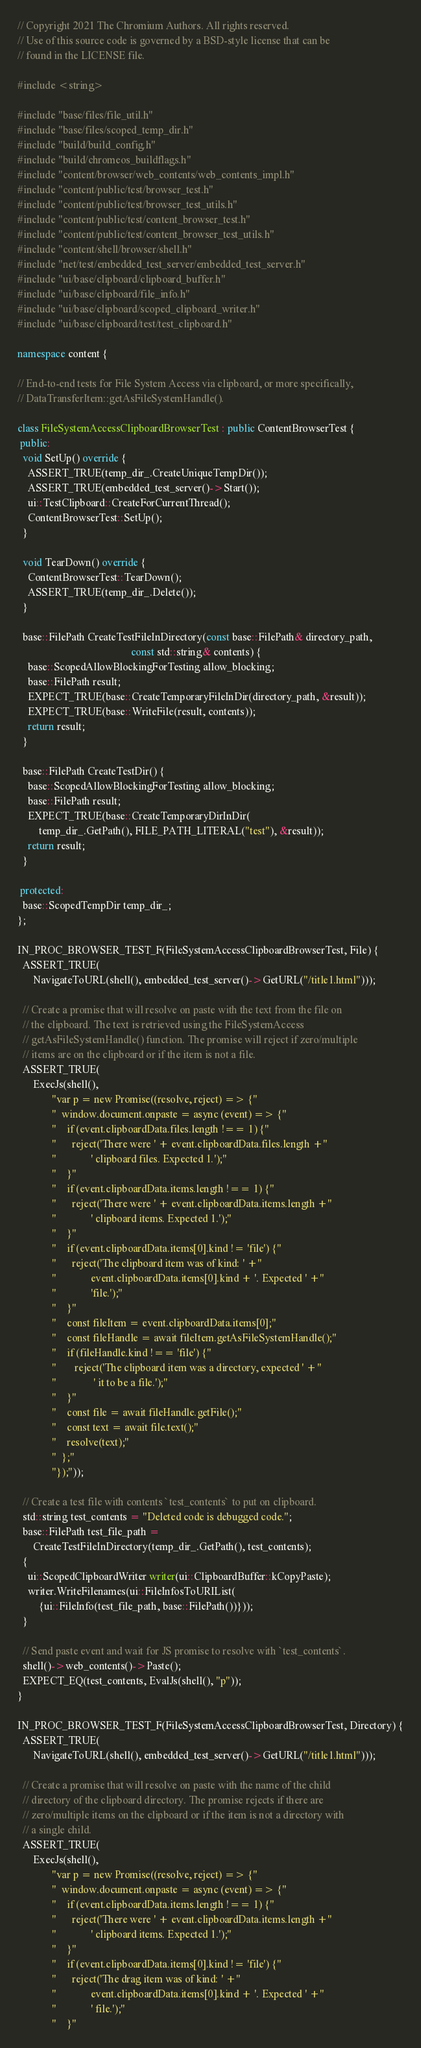<code> <loc_0><loc_0><loc_500><loc_500><_C++_>// Copyright 2021 The Chromium Authors. All rights reserved.
// Use of this source code is governed by a BSD-style license that can be
// found in the LICENSE file.

#include <string>

#include "base/files/file_util.h"
#include "base/files/scoped_temp_dir.h"
#include "build/build_config.h"
#include "build/chromeos_buildflags.h"
#include "content/browser/web_contents/web_contents_impl.h"
#include "content/public/test/browser_test.h"
#include "content/public/test/browser_test_utils.h"
#include "content/public/test/content_browser_test.h"
#include "content/public/test/content_browser_test_utils.h"
#include "content/shell/browser/shell.h"
#include "net/test/embedded_test_server/embedded_test_server.h"
#include "ui/base/clipboard/clipboard_buffer.h"
#include "ui/base/clipboard/file_info.h"
#include "ui/base/clipboard/scoped_clipboard_writer.h"
#include "ui/base/clipboard/test/test_clipboard.h"

namespace content {

// End-to-end tests for File System Access via clipboard, or more specifically,
// DataTransferItem::getAsFileSystemHandle().

class FileSystemAccessClipboardBrowserTest : public ContentBrowserTest {
 public:
  void SetUp() override {
    ASSERT_TRUE(temp_dir_.CreateUniqueTempDir());
    ASSERT_TRUE(embedded_test_server()->Start());
    ui::TestClipboard::CreateForCurrentThread();
    ContentBrowserTest::SetUp();
  }

  void TearDown() override {
    ContentBrowserTest::TearDown();
    ASSERT_TRUE(temp_dir_.Delete());
  }

  base::FilePath CreateTestFileInDirectory(const base::FilePath& directory_path,
                                           const std::string& contents) {
    base::ScopedAllowBlockingForTesting allow_blocking;
    base::FilePath result;
    EXPECT_TRUE(base::CreateTemporaryFileInDir(directory_path, &result));
    EXPECT_TRUE(base::WriteFile(result, contents));
    return result;
  }

  base::FilePath CreateTestDir() {
    base::ScopedAllowBlockingForTesting allow_blocking;
    base::FilePath result;
    EXPECT_TRUE(base::CreateTemporaryDirInDir(
        temp_dir_.GetPath(), FILE_PATH_LITERAL("test"), &result));
    return result;
  }

 protected:
  base::ScopedTempDir temp_dir_;
};

IN_PROC_BROWSER_TEST_F(FileSystemAccessClipboardBrowserTest, File) {
  ASSERT_TRUE(
      NavigateToURL(shell(), embedded_test_server()->GetURL("/title1.html")));

  // Create a promise that will resolve on paste with the text from the file on
  // the clipboard. The text is retrieved using the FileSystemAccess
  // getAsFileSystemHandle() function. The promise will reject if zero/multiple
  // items are on the clipboard or if the item is not a file.
  ASSERT_TRUE(
      ExecJs(shell(),
             "var p = new Promise((resolve, reject) => {"
             "  window.document.onpaste = async (event) => {"
             "    if (event.clipboardData.files.length !== 1) {"
             "      reject('There were ' + event.clipboardData.files.length +"
             "             ' clipboard files. Expected 1.');"
             "    }"
             "    if (event.clipboardData.items.length !== 1) {"
             "      reject('There were ' + event.clipboardData.items.length +"
             "             ' clipboard items. Expected 1.');"
             "    }"
             "    if (event.clipboardData.items[0].kind != 'file') {"
             "      reject('The clipboard item was of kind: ' +"
             "             event.clipboardData.items[0].kind + '. Expected ' +"
             "             'file.');"
             "    }"
             "    const fileItem = event.clipboardData.items[0];"
             "    const fileHandle = await fileItem.getAsFileSystemHandle();"
             "    if (fileHandle.kind !== 'file') {"
             "       reject('The clipboard item was a directory, expected ' +"
             "              ' it to be a file.');"
             "    }"
             "    const file = await fileHandle.getFile();"
             "    const text = await file.text();"
             "    resolve(text);"
             "  };"
             "});"));

  // Create a test file with contents `test_contents` to put on clipboard.
  std::string test_contents = "Deleted code is debugged code.";
  base::FilePath test_file_path =
      CreateTestFileInDirectory(temp_dir_.GetPath(), test_contents);
  {
    ui::ScopedClipboardWriter writer(ui::ClipboardBuffer::kCopyPaste);
    writer.WriteFilenames(ui::FileInfosToURIList(
        {ui::FileInfo(test_file_path, base::FilePath())}));
  }

  // Send paste event and wait for JS promise to resolve with `test_contents`.
  shell()->web_contents()->Paste();
  EXPECT_EQ(test_contents, EvalJs(shell(), "p"));
}

IN_PROC_BROWSER_TEST_F(FileSystemAccessClipboardBrowserTest, Directory) {
  ASSERT_TRUE(
      NavigateToURL(shell(), embedded_test_server()->GetURL("/title1.html")));

  // Create a promise that will resolve on paste with the name of the child
  // directory of the clipboard directory. The promise rejects if there are
  // zero/multiple items on the clipboard or if the item is not a directory with
  // a single child.
  ASSERT_TRUE(
      ExecJs(shell(),
             "var p = new Promise((resolve, reject) => {"
             "  window.document.onpaste = async (event) => {"
             "    if (event.clipboardData.items.length !== 1) {"
             "      reject('There were ' + event.clipboardData.items.length +"
             "             ' clipboard items. Expected 1.');"
             "    }"
             "    if (event.clipboardData.items[0].kind != 'file') {"
             "      reject('The drag item was of kind: ' +"
             "             event.clipboardData.items[0].kind + '. Expected ' +"
             "             ' file.');"
             "    }"</code> 